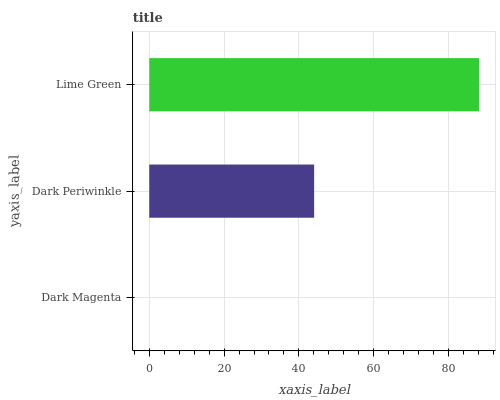Is Dark Magenta the minimum?
Answer yes or no. Yes. Is Lime Green the maximum?
Answer yes or no. Yes. Is Dark Periwinkle the minimum?
Answer yes or no. No. Is Dark Periwinkle the maximum?
Answer yes or no. No. Is Dark Periwinkle greater than Dark Magenta?
Answer yes or no. Yes. Is Dark Magenta less than Dark Periwinkle?
Answer yes or no. Yes. Is Dark Magenta greater than Dark Periwinkle?
Answer yes or no. No. Is Dark Periwinkle less than Dark Magenta?
Answer yes or no. No. Is Dark Periwinkle the high median?
Answer yes or no. Yes. Is Dark Periwinkle the low median?
Answer yes or no. Yes. Is Dark Magenta the high median?
Answer yes or no. No. Is Dark Magenta the low median?
Answer yes or no. No. 